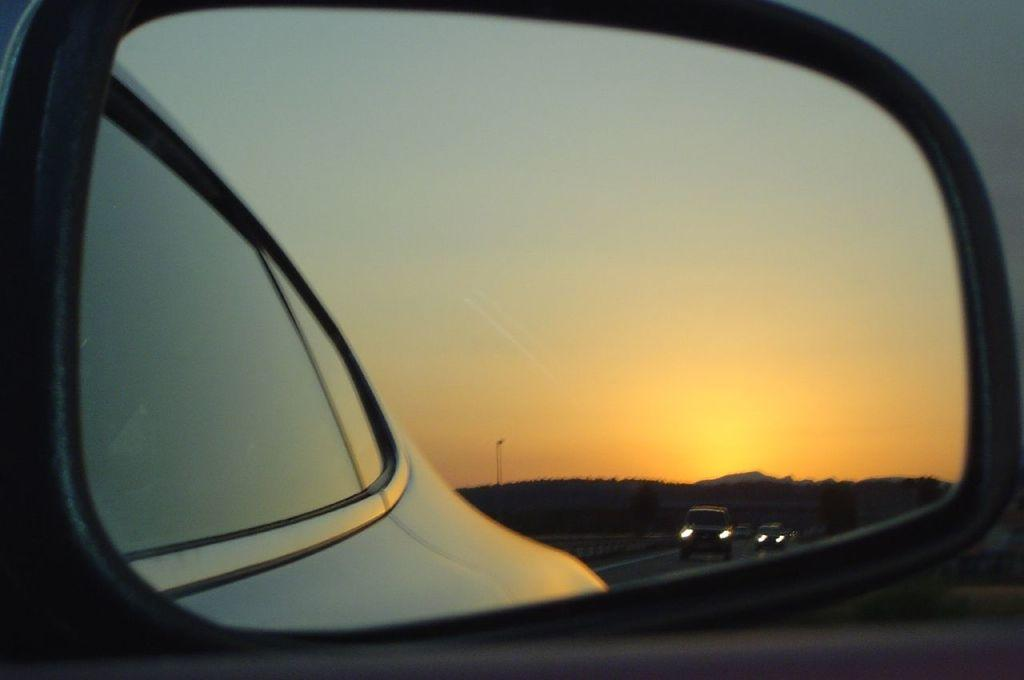What is the main object in the foreground of the image? There is a car mirror in the foreground of the image. What type of natural elements can be seen in the image? Trees are visible in the image. What type of man-made objects are present in the image? Vehicles and a pole are present in the image. What is visible in the background of the image? The sky is visible in the image. How many beds can be seen in the image? There are no beds present in the image. What type of bag is being carried by the person in the image? There is no person carrying a bag in the image. 